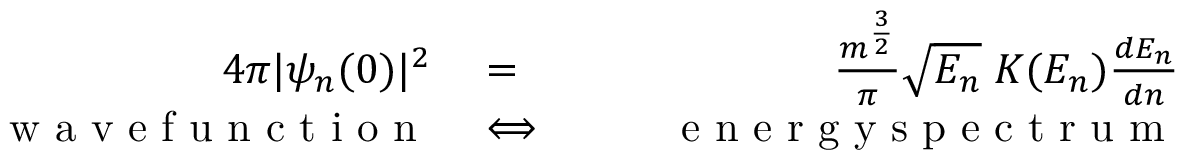<formula> <loc_0><loc_0><loc_500><loc_500>\begin{array} { r l r } { 4 \pi | \psi _ { n } ( 0 ) | ^ { 2 } } & = } & { \frac { m ^ { \frac { 3 } { 2 } } } { \pi } \sqrt { E _ { n } } \, K ( E _ { n } ) \frac { d E _ { n } } { d n } } \\ { \quad w a v e f u n c t i o n } & \Longleftrightarrow } & { \quad e n e r g y s p e c t r u m } \end{array}</formula> 